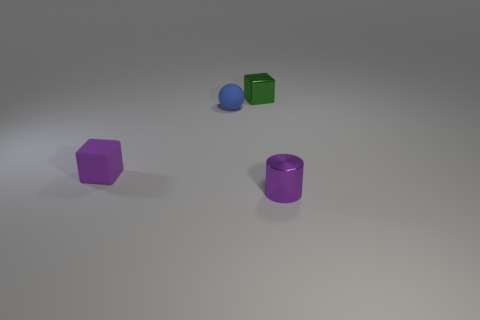Add 1 cubes. How many objects exist? 5 Subtract 2 cubes. How many cubes are left? 0 Subtract all green cubes. How many cubes are left? 1 Subtract all matte spheres. Subtract all small purple shiny things. How many objects are left? 2 Add 4 green metal objects. How many green metal objects are left? 5 Add 1 small blue matte spheres. How many small blue matte spheres exist? 2 Subtract 0 blue cylinders. How many objects are left? 4 Subtract all spheres. How many objects are left? 3 Subtract all brown blocks. Subtract all red cylinders. How many blocks are left? 2 